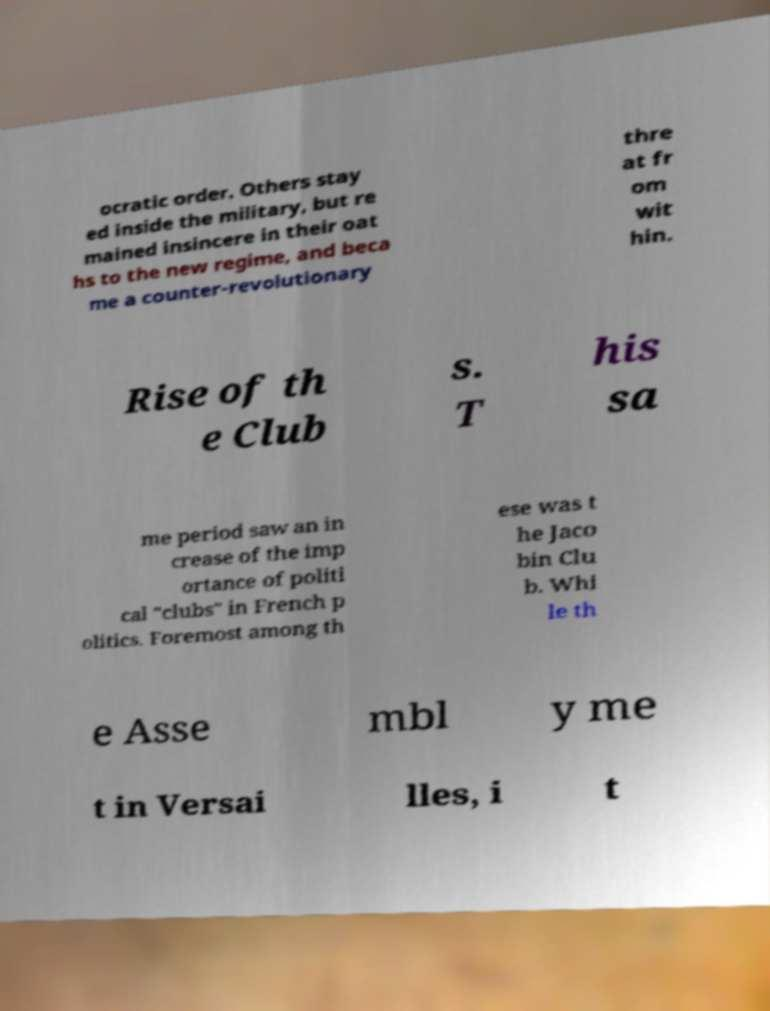Please read and relay the text visible in this image. What does it say? ocratic order. Others stay ed inside the military, but re mained insincere in their oat hs to the new regime, and beca me a counter-revolutionary thre at fr om wit hin. Rise of th e Club s. T his sa me period saw an in crease of the imp ortance of politi cal "clubs" in French p olitics. Foremost among th ese was t he Jaco bin Clu b. Whi le th e Asse mbl y me t in Versai lles, i t 